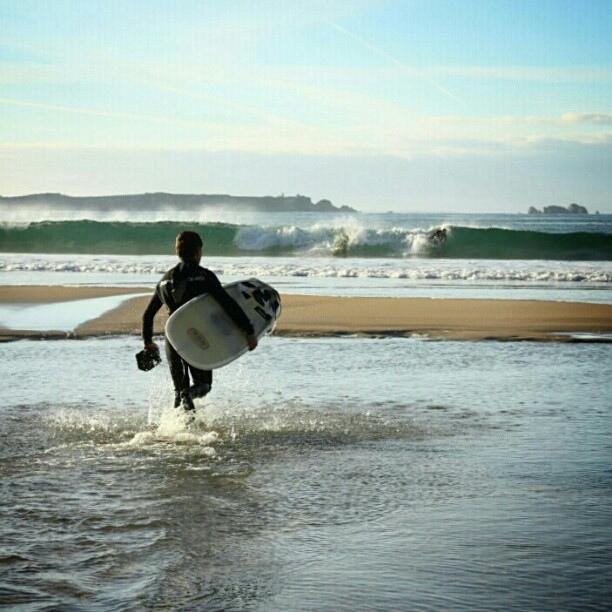Which way is the surfer headed?
Quick response, please. Towards waves. Is this a professional surfer?
Write a very short answer. Yes. What is the surfer carrying on his left hand?
Answer briefly. Camera. 